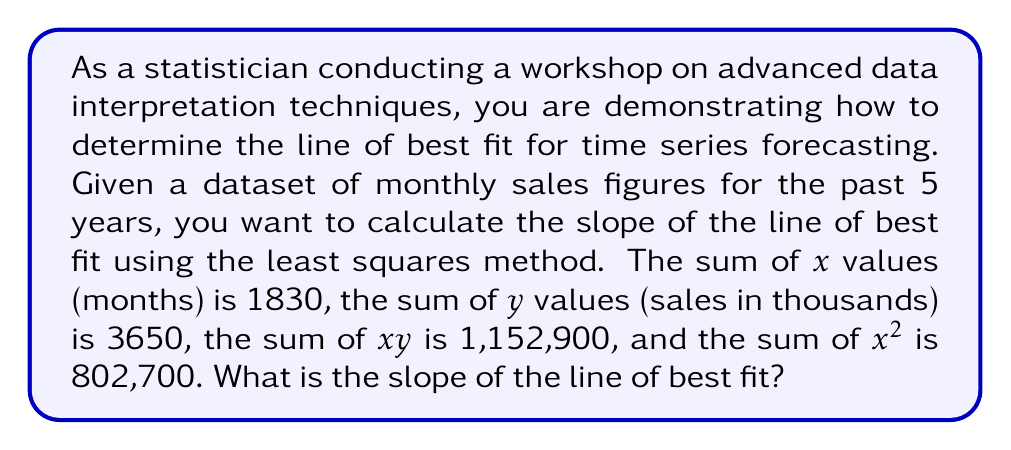Show me your answer to this math problem. To determine the slope of the line of best fit using the least squares method, we use the formula:

$$ m = \frac{n\sum xy - \sum x \sum y}{n\sum x^2 - (\sum x)^2} $$

Where:
- $m$ is the slope
- $n$ is the number of data points
- $\sum xy$ is the sum of the product of x and y
- $\sum x$ is the sum of x values
- $\sum y$ is the sum of y values
- $\sum x^2$ is the sum of squared x values

Given:
- $\sum x = 1830$
- $\sum y = 3650$
- $\sum xy = 1,152,900$
- $\sum x^2 = 802,700$
- $n = 60$ (5 years * 12 months)

Let's substitute these values into the formula:

$$ m = \frac{60(1,152,900) - (1830)(3650)}{60(802,700) - (1830)^2} $$

$$ m = \frac{69,174,000 - 6,679,500}{48,162,000 - 3,348,900} $$

$$ m = \frac{62,494,500}{44,813,100} $$

$$ m \approx 1.3945 $$
Answer: $1.3945$ 